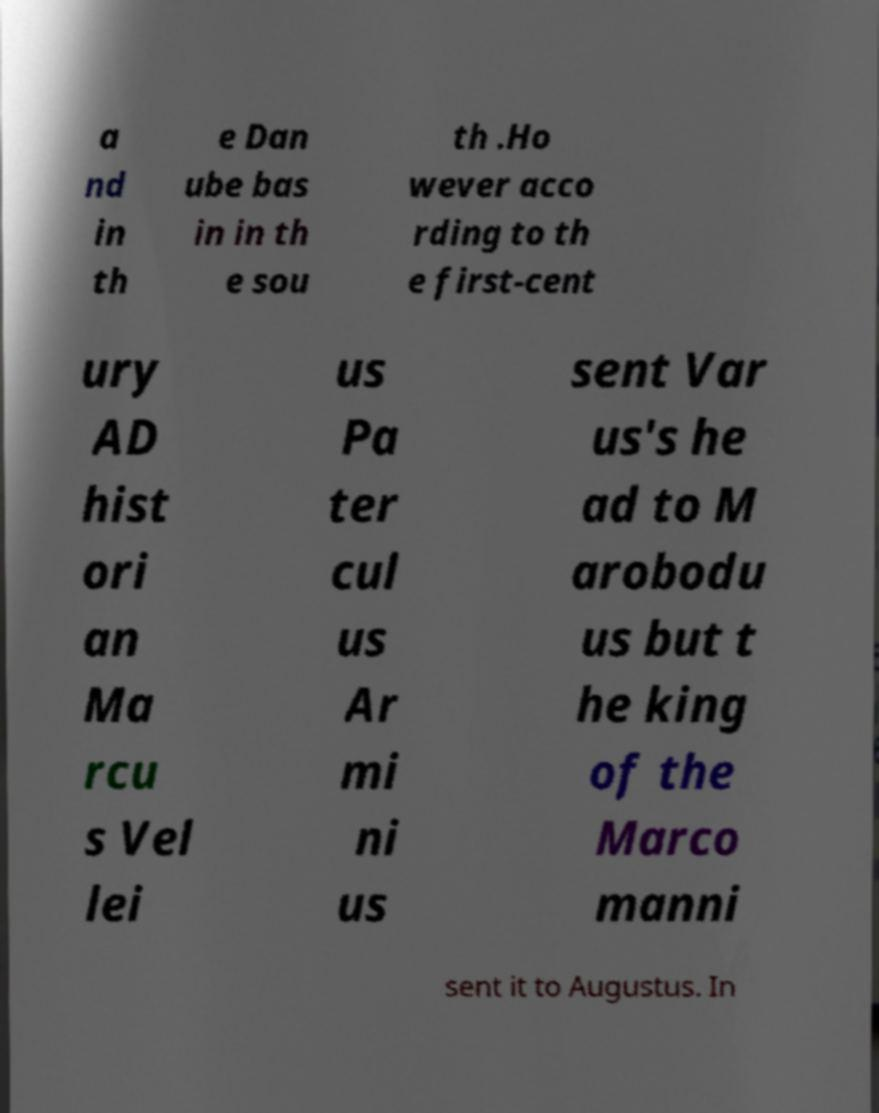Can you read and provide the text displayed in the image?This photo seems to have some interesting text. Can you extract and type it out for me? a nd in th e Dan ube bas in in th e sou th .Ho wever acco rding to th e first-cent ury AD hist ori an Ma rcu s Vel lei us Pa ter cul us Ar mi ni us sent Var us's he ad to M arobodu us but t he king of the Marco manni sent it to Augustus. In 